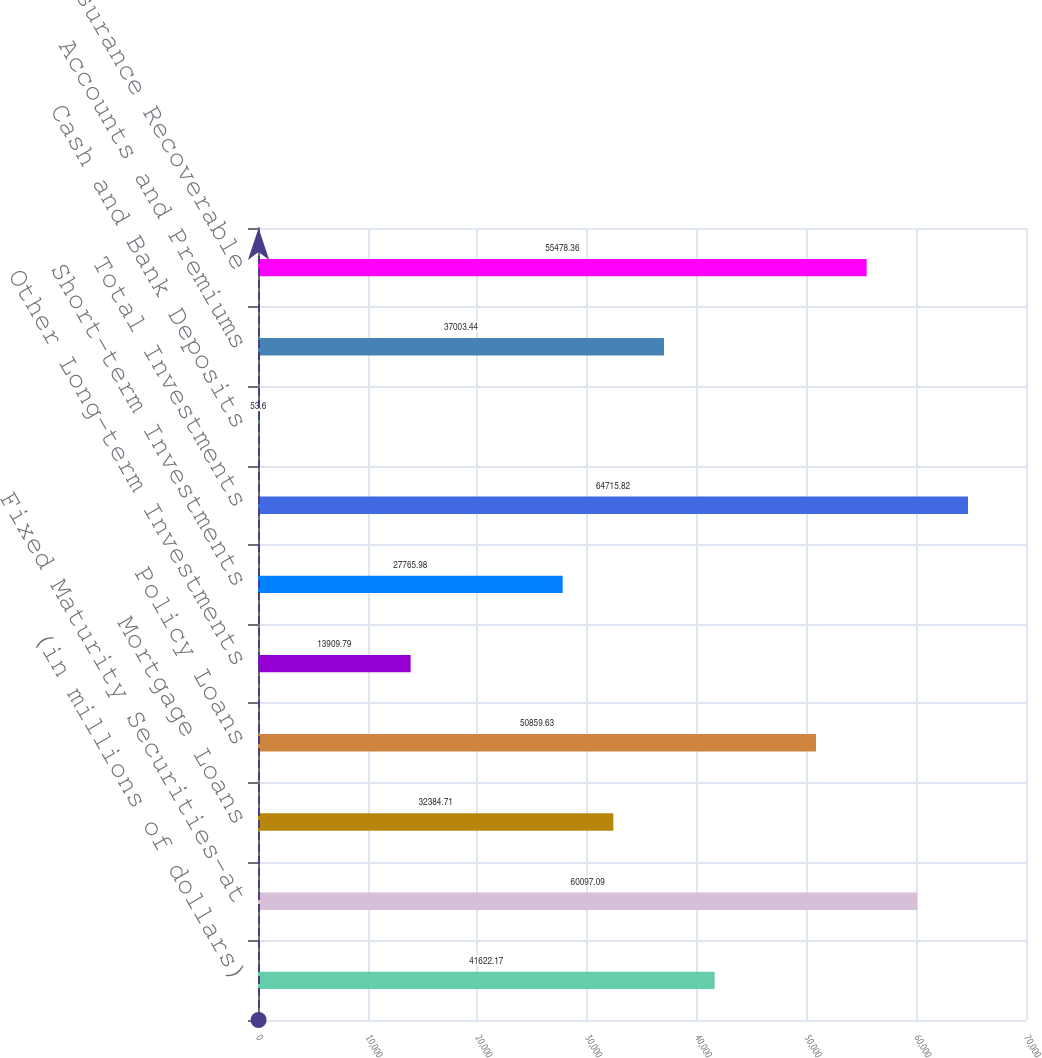<chart> <loc_0><loc_0><loc_500><loc_500><bar_chart><fcel>(in millions of dollars)<fcel>Fixed Maturity Securities-at<fcel>Mortgage Loans<fcel>Policy Loans<fcel>Other Long-term Investments<fcel>Short-term Investments<fcel>Total Investments<fcel>Cash and Bank Deposits<fcel>Accounts and Premiums<fcel>Reinsurance Recoverable<nl><fcel>41622.2<fcel>60097.1<fcel>32384.7<fcel>50859.6<fcel>13909.8<fcel>27766<fcel>64715.8<fcel>53.6<fcel>37003.4<fcel>55478.4<nl></chart> 